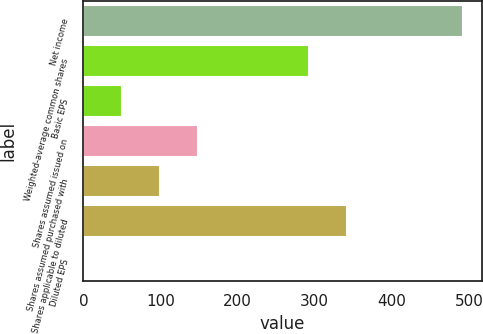Convert chart. <chart><loc_0><loc_0><loc_500><loc_500><bar_chart><fcel>Net income<fcel>Weighted-average common shares<fcel>Basic EPS<fcel>Shares assumed issued on<fcel>Shares assumed purchased with<fcel>Shares applicable to diluted<fcel>Diluted EPS<nl><fcel>492<fcel>293<fcel>50.66<fcel>148.74<fcel>99.7<fcel>342.04<fcel>1.62<nl></chart> 